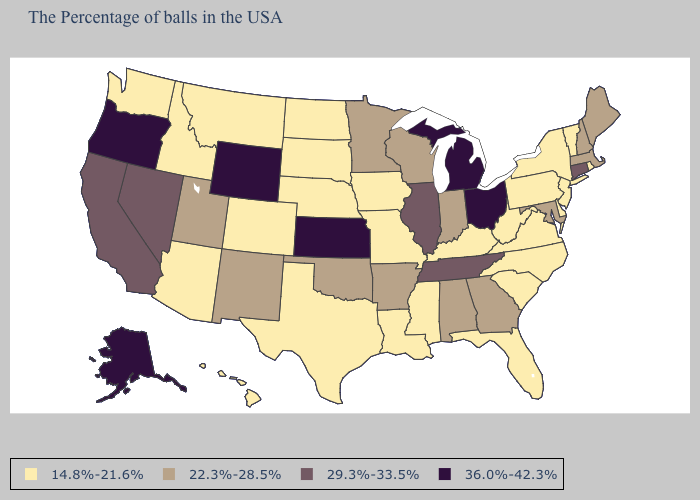Does Arkansas have the lowest value in the South?
Short answer required. No. What is the value of Colorado?
Be succinct. 14.8%-21.6%. What is the value of Maryland?
Answer briefly. 22.3%-28.5%. Name the states that have a value in the range 36.0%-42.3%?
Answer briefly. Ohio, Michigan, Kansas, Wyoming, Oregon, Alaska. Does the first symbol in the legend represent the smallest category?
Short answer required. Yes. What is the value of Alabama?
Keep it brief. 22.3%-28.5%. Name the states that have a value in the range 36.0%-42.3%?
Answer briefly. Ohio, Michigan, Kansas, Wyoming, Oregon, Alaska. Name the states that have a value in the range 22.3%-28.5%?
Short answer required. Maine, Massachusetts, New Hampshire, Maryland, Georgia, Indiana, Alabama, Wisconsin, Arkansas, Minnesota, Oklahoma, New Mexico, Utah. Does Connecticut have the highest value in the Northeast?
Write a very short answer. Yes. What is the lowest value in the USA?
Write a very short answer. 14.8%-21.6%. What is the value of Arizona?
Concise answer only. 14.8%-21.6%. Does Oregon have the highest value in the West?
Be succinct. Yes. Name the states that have a value in the range 22.3%-28.5%?
Write a very short answer. Maine, Massachusetts, New Hampshire, Maryland, Georgia, Indiana, Alabama, Wisconsin, Arkansas, Minnesota, Oklahoma, New Mexico, Utah. 